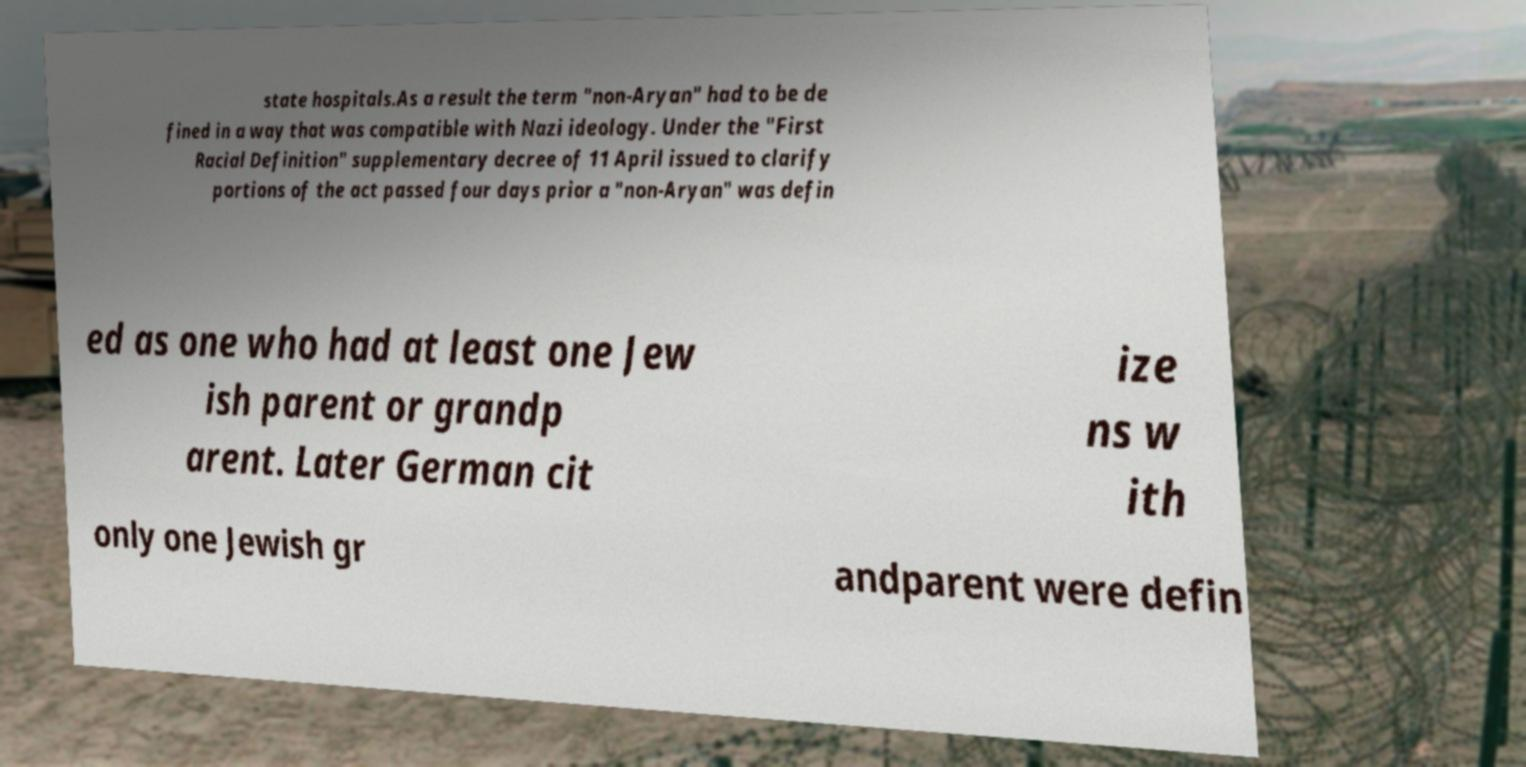What messages or text are displayed in this image? I need them in a readable, typed format. state hospitals.As a result the term "non-Aryan" had to be de fined in a way that was compatible with Nazi ideology. Under the "First Racial Definition" supplementary decree of 11 April issued to clarify portions of the act passed four days prior a "non-Aryan" was defin ed as one who had at least one Jew ish parent or grandp arent. Later German cit ize ns w ith only one Jewish gr andparent were defin 